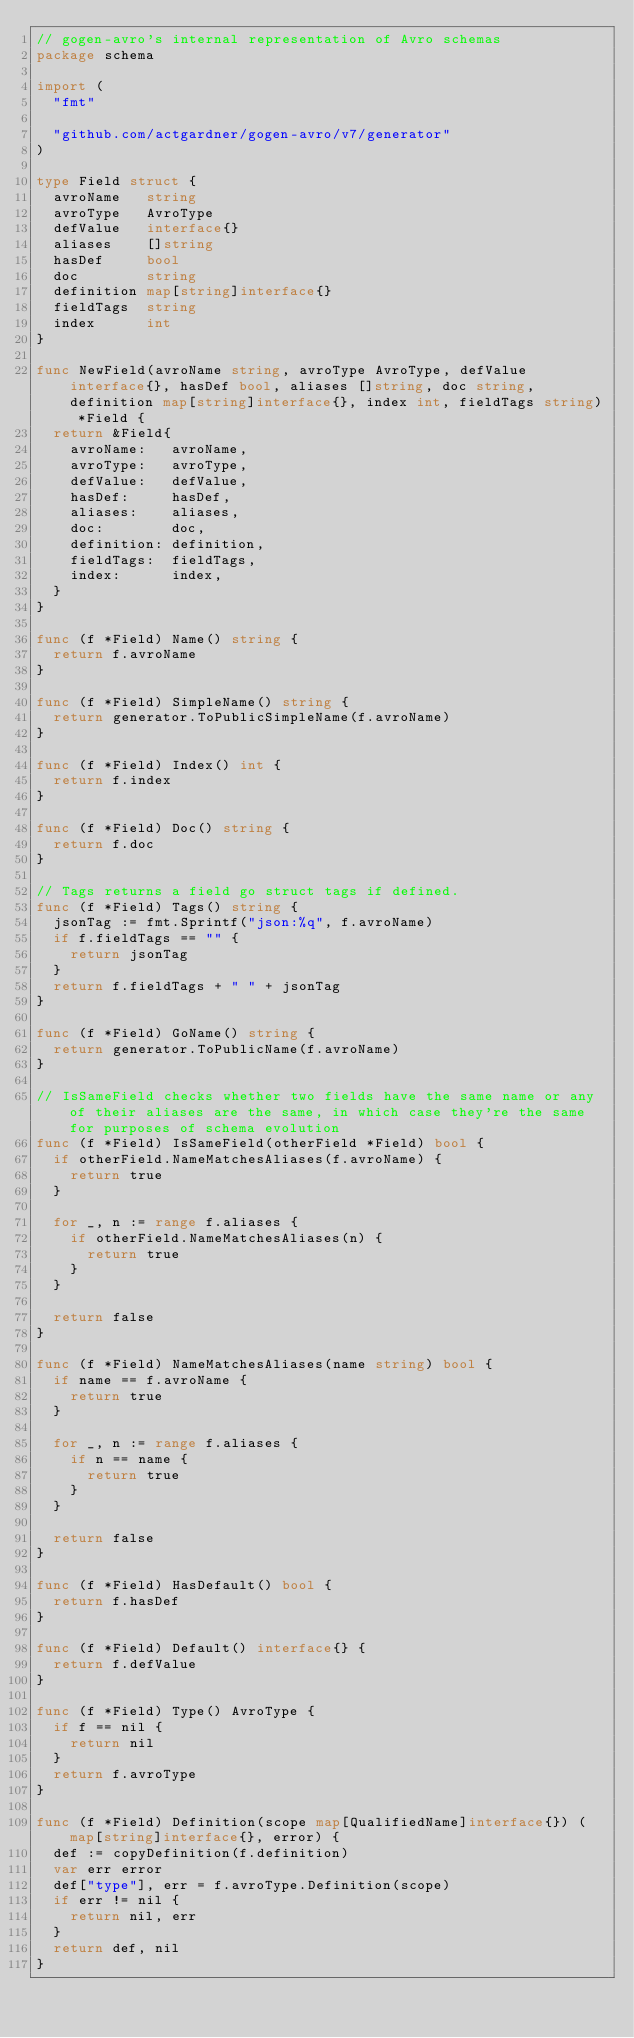Convert code to text. <code><loc_0><loc_0><loc_500><loc_500><_Go_>// gogen-avro's internal representation of Avro schemas
package schema

import (
	"fmt"

	"github.com/actgardner/gogen-avro/v7/generator"
)

type Field struct {
	avroName   string
	avroType   AvroType
	defValue   interface{}
	aliases    []string
	hasDef     bool
	doc        string
	definition map[string]interface{}
	fieldTags  string
	index      int
}

func NewField(avroName string, avroType AvroType, defValue interface{}, hasDef bool, aliases []string, doc string, definition map[string]interface{}, index int, fieldTags string) *Field {
	return &Field{
		avroName:   avroName,
		avroType:   avroType,
		defValue:   defValue,
		hasDef:     hasDef,
		aliases:    aliases,
		doc:        doc,
		definition: definition,
		fieldTags:  fieldTags,
		index:      index,
	}
}

func (f *Field) Name() string {
	return f.avroName
}

func (f *Field) SimpleName() string {
	return generator.ToPublicSimpleName(f.avroName)
}

func (f *Field) Index() int {
	return f.index
}

func (f *Field) Doc() string {
	return f.doc
}

// Tags returns a field go struct tags if defined.
func (f *Field) Tags() string {
	jsonTag := fmt.Sprintf("json:%q", f.avroName)
	if f.fieldTags == "" {
		return jsonTag
	}
	return f.fieldTags + " " + jsonTag
}

func (f *Field) GoName() string {
	return generator.ToPublicName(f.avroName)
}

// IsSameField checks whether two fields have the same name or any of their aliases are the same, in which case they're the same for purposes of schema evolution
func (f *Field) IsSameField(otherField *Field) bool {
	if otherField.NameMatchesAliases(f.avroName) {
		return true
	}

	for _, n := range f.aliases {
		if otherField.NameMatchesAliases(n) {
			return true
		}
	}

	return false
}

func (f *Field) NameMatchesAliases(name string) bool {
	if name == f.avroName {
		return true
	}

	for _, n := range f.aliases {
		if n == name {
			return true
		}
	}

	return false
}

func (f *Field) HasDefault() bool {
	return f.hasDef
}

func (f *Field) Default() interface{} {
	return f.defValue
}

func (f *Field) Type() AvroType {
	if f == nil {
		return nil
	}
	return f.avroType
}

func (f *Field) Definition(scope map[QualifiedName]interface{}) (map[string]interface{}, error) {
	def := copyDefinition(f.definition)
	var err error
	def["type"], err = f.avroType.Definition(scope)
	if err != nil {
		return nil, err
	}
	return def, nil
}
</code> 